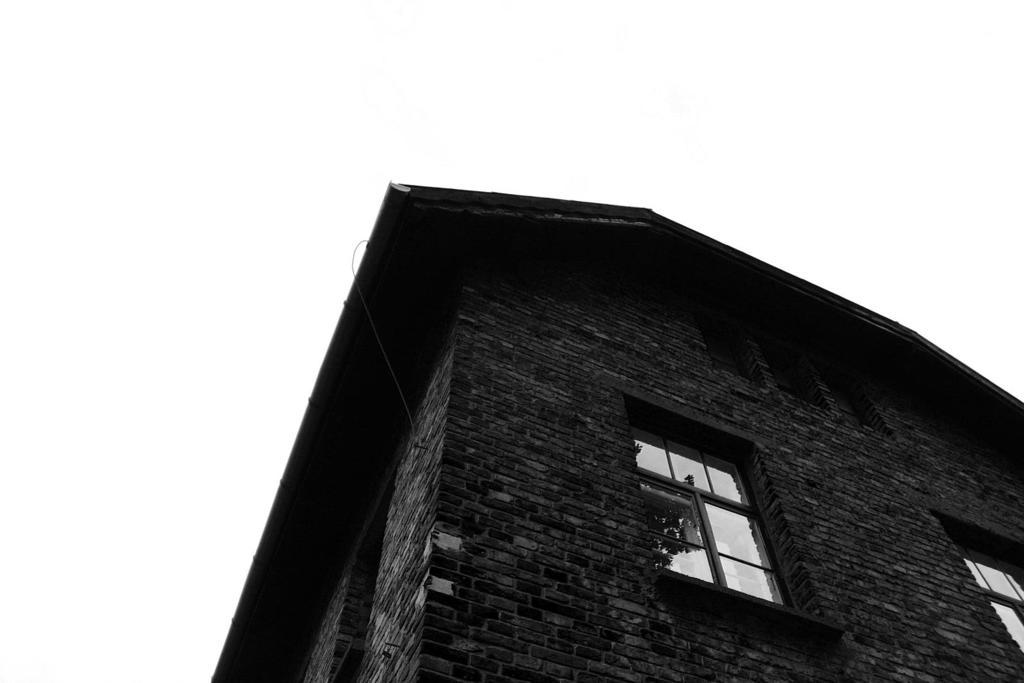What is the color scheme of the image? The image is black and white. What is the main subject of the image? There is a building in the image. What specific features can be observed on the building? The building has windows. Can you tell me how many buttons are on the hair of the person in the image? There is no person present in the image, and therefore no hair or buttons can be observed. 